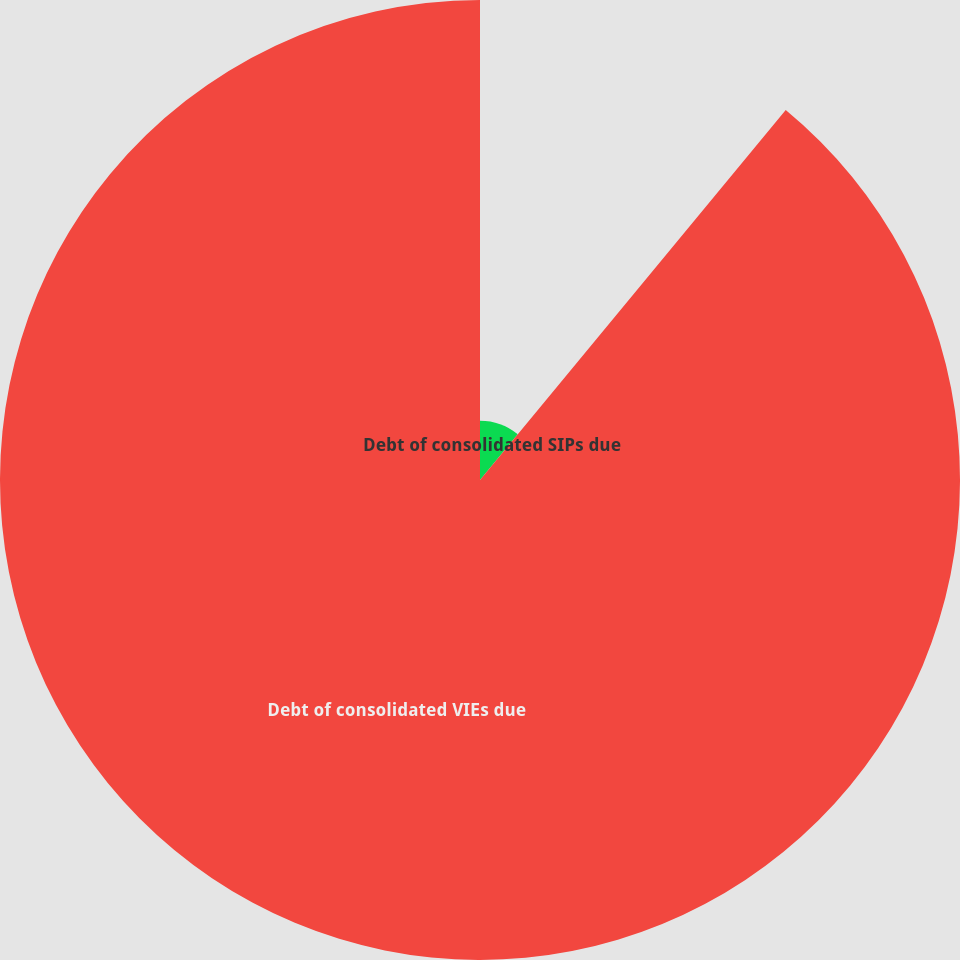<chart> <loc_0><loc_0><loc_500><loc_500><pie_chart><fcel>Debt of consolidated SIPs due<fcel>Debt of consolidated VIEs due<nl><fcel>10.99%<fcel>89.01%<nl></chart> 